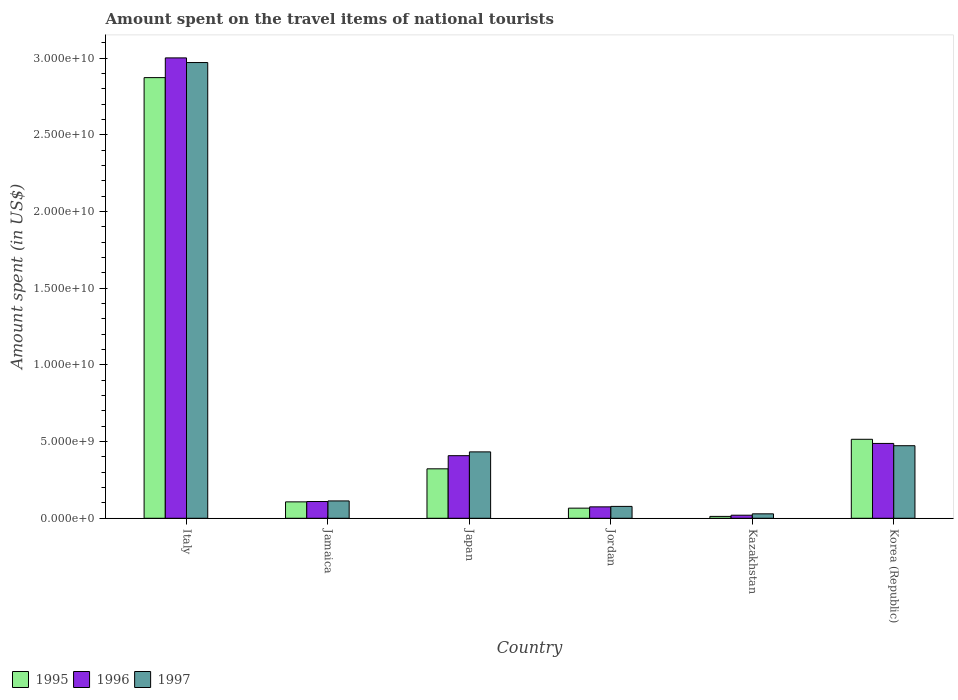Are the number of bars per tick equal to the number of legend labels?
Your answer should be compact. Yes. Are the number of bars on each tick of the X-axis equal?
Offer a very short reply. Yes. How many bars are there on the 4th tick from the left?
Your response must be concise. 3. In how many cases, is the number of bars for a given country not equal to the number of legend labels?
Your answer should be very brief. 0. What is the amount spent on the travel items of national tourists in 1995 in Italy?
Offer a terse response. 2.87e+1. Across all countries, what is the maximum amount spent on the travel items of national tourists in 1995?
Provide a succinct answer. 2.87e+1. Across all countries, what is the minimum amount spent on the travel items of national tourists in 1996?
Offer a terse response. 1.99e+08. In which country was the amount spent on the travel items of national tourists in 1996 minimum?
Provide a short and direct response. Kazakhstan. What is the total amount spent on the travel items of national tourists in 1996 in the graph?
Provide a succinct answer. 4.10e+1. What is the difference between the amount spent on the travel items of national tourists in 1996 in Italy and that in Japan?
Your answer should be compact. 2.59e+1. What is the difference between the amount spent on the travel items of national tourists in 1996 in Italy and the amount spent on the travel items of national tourists in 1997 in Kazakhstan?
Make the answer very short. 2.97e+1. What is the average amount spent on the travel items of national tourists in 1997 per country?
Give a very brief answer. 6.83e+09. What is the difference between the amount spent on the travel items of national tourists of/in 1997 and amount spent on the travel items of national tourists of/in 1996 in Japan?
Ensure brevity in your answer.  2.48e+08. In how many countries, is the amount spent on the travel items of national tourists in 1995 greater than 21000000000 US$?
Give a very brief answer. 1. What is the ratio of the amount spent on the travel items of national tourists in 1996 in Italy to that in Japan?
Provide a succinct answer. 7.36. Is the difference between the amount spent on the travel items of national tourists in 1997 in Jamaica and Japan greater than the difference between the amount spent on the travel items of national tourists in 1996 in Jamaica and Japan?
Provide a short and direct response. No. What is the difference between the highest and the second highest amount spent on the travel items of national tourists in 1995?
Provide a short and direct response. 2.55e+1. What is the difference between the highest and the lowest amount spent on the travel items of national tourists in 1997?
Your answer should be very brief. 2.94e+1. In how many countries, is the amount spent on the travel items of national tourists in 1997 greater than the average amount spent on the travel items of national tourists in 1997 taken over all countries?
Your response must be concise. 1. Is the sum of the amount spent on the travel items of national tourists in 1995 in Jamaica and Japan greater than the maximum amount spent on the travel items of national tourists in 1996 across all countries?
Keep it short and to the point. No. What does the 3rd bar from the left in Korea (Republic) represents?
Offer a terse response. 1997. What does the 1st bar from the right in Korea (Republic) represents?
Your answer should be compact. 1997. Is it the case that in every country, the sum of the amount spent on the travel items of national tourists in 1996 and amount spent on the travel items of national tourists in 1997 is greater than the amount spent on the travel items of national tourists in 1995?
Give a very brief answer. Yes. Are all the bars in the graph horizontal?
Your response must be concise. No. Does the graph contain any zero values?
Provide a short and direct response. No. Does the graph contain grids?
Your answer should be compact. No. What is the title of the graph?
Give a very brief answer. Amount spent on the travel items of national tourists. Does "1960" appear as one of the legend labels in the graph?
Offer a terse response. No. What is the label or title of the Y-axis?
Your answer should be very brief. Amount spent (in US$). What is the Amount spent (in US$) of 1995 in Italy?
Provide a short and direct response. 2.87e+1. What is the Amount spent (in US$) of 1996 in Italy?
Provide a short and direct response. 3.00e+1. What is the Amount spent (in US$) in 1997 in Italy?
Offer a very short reply. 2.97e+1. What is the Amount spent (in US$) of 1995 in Jamaica?
Offer a very short reply. 1.07e+09. What is the Amount spent (in US$) of 1996 in Jamaica?
Your answer should be very brief. 1.09e+09. What is the Amount spent (in US$) in 1997 in Jamaica?
Provide a succinct answer. 1.13e+09. What is the Amount spent (in US$) of 1995 in Japan?
Offer a terse response. 3.22e+09. What is the Amount spent (in US$) of 1996 in Japan?
Give a very brief answer. 4.08e+09. What is the Amount spent (in US$) in 1997 in Japan?
Give a very brief answer. 4.33e+09. What is the Amount spent (in US$) in 1995 in Jordan?
Provide a succinct answer. 6.60e+08. What is the Amount spent (in US$) of 1996 in Jordan?
Provide a short and direct response. 7.44e+08. What is the Amount spent (in US$) of 1997 in Jordan?
Offer a terse response. 7.74e+08. What is the Amount spent (in US$) of 1995 in Kazakhstan?
Give a very brief answer. 1.22e+08. What is the Amount spent (in US$) of 1996 in Kazakhstan?
Ensure brevity in your answer.  1.99e+08. What is the Amount spent (in US$) of 1997 in Kazakhstan?
Ensure brevity in your answer.  2.89e+08. What is the Amount spent (in US$) in 1995 in Korea (Republic)?
Your response must be concise. 5.15e+09. What is the Amount spent (in US$) of 1996 in Korea (Republic)?
Make the answer very short. 4.88e+09. What is the Amount spent (in US$) in 1997 in Korea (Republic)?
Offer a very short reply. 4.73e+09. Across all countries, what is the maximum Amount spent (in US$) in 1995?
Make the answer very short. 2.87e+1. Across all countries, what is the maximum Amount spent (in US$) of 1996?
Your answer should be very brief. 3.00e+1. Across all countries, what is the maximum Amount spent (in US$) of 1997?
Make the answer very short. 2.97e+1. Across all countries, what is the minimum Amount spent (in US$) of 1995?
Your response must be concise. 1.22e+08. Across all countries, what is the minimum Amount spent (in US$) in 1996?
Keep it short and to the point. 1.99e+08. Across all countries, what is the minimum Amount spent (in US$) in 1997?
Keep it short and to the point. 2.89e+08. What is the total Amount spent (in US$) of 1995 in the graph?
Offer a very short reply. 3.90e+1. What is the total Amount spent (in US$) of 1996 in the graph?
Your response must be concise. 4.10e+1. What is the total Amount spent (in US$) in 1997 in the graph?
Provide a short and direct response. 4.10e+1. What is the difference between the Amount spent (in US$) of 1995 in Italy and that in Jamaica?
Provide a short and direct response. 2.77e+1. What is the difference between the Amount spent (in US$) in 1996 in Italy and that in Jamaica?
Give a very brief answer. 2.89e+1. What is the difference between the Amount spent (in US$) of 1997 in Italy and that in Jamaica?
Offer a terse response. 2.86e+1. What is the difference between the Amount spent (in US$) of 1995 in Italy and that in Japan?
Keep it short and to the point. 2.55e+1. What is the difference between the Amount spent (in US$) in 1996 in Italy and that in Japan?
Your answer should be very brief. 2.59e+1. What is the difference between the Amount spent (in US$) of 1997 in Italy and that in Japan?
Provide a succinct answer. 2.54e+1. What is the difference between the Amount spent (in US$) in 1995 in Italy and that in Jordan?
Your answer should be compact. 2.81e+1. What is the difference between the Amount spent (in US$) in 1996 in Italy and that in Jordan?
Your answer should be compact. 2.93e+1. What is the difference between the Amount spent (in US$) of 1997 in Italy and that in Jordan?
Give a very brief answer. 2.89e+1. What is the difference between the Amount spent (in US$) in 1995 in Italy and that in Kazakhstan?
Keep it short and to the point. 2.86e+1. What is the difference between the Amount spent (in US$) in 1996 in Italy and that in Kazakhstan?
Keep it short and to the point. 2.98e+1. What is the difference between the Amount spent (in US$) in 1997 in Italy and that in Kazakhstan?
Keep it short and to the point. 2.94e+1. What is the difference between the Amount spent (in US$) in 1995 in Italy and that in Korea (Republic)?
Provide a short and direct response. 2.36e+1. What is the difference between the Amount spent (in US$) of 1996 in Italy and that in Korea (Republic)?
Make the answer very short. 2.51e+1. What is the difference between the Amount spent (in US$) in 1997 in Italy and that in Korea (Republic)?
Make the answer very short. 2.50e+1. What is the difference between the Amount spent (in US$) in 1995 in Jamaica and that in Japan?
Provide a short and direct response. -2.16e+09. What is the difference between the Amount spent (in US$) in 1996 in Jamaica and that in Japan?
Make the answer very short. -2.99e+09. What is the difference between the Amount spent (in US$) in 1997 in Jamaica and that in Japan?
Make the answer very short. -3.20e+09. What is the difference between the Amount spent (in US$) of 1995 in Jamaica and that in Jordan?
Give a very brief answer. 4.09e+08. What is the difference between the Amount spent (in US$) of 1996 in Jamaica and that in Jordan?
Keep it short and to the point. 3.48e+08. What is the difference between the Amount spent (in US$) of 1997 in Jamaica and that in Jordan?
Provide a succinct answer. 3.57e+08. What is the difference between the Amount spent (in US$) of 1995 in Jamaica and that in Kazakhstan?
Offer a terse response. 9.47e+08. What is the difference between the Amount spent (in US$) in 1996 in Jamaica and that in Kazakhstan?
Give a very brief answer. 8.93e+08. What is the difference between the Amount spent (in US$) in 1997 in Jamaica and that in Kazakhstan?
Offer a very short reply. 8.42e+08. What is the difference between the Amount spent (in US$) of 1995 in Jamaica and that in Korea (Republic)?
Offer a terse response. -4.08e+09. What is the difference between the Amount spent (in US$) of 1996 in Jamaica and that in Korea (Republic)?
Your response must be concise. -3.79e+09. What is the difference between the Amount spent (in US$) of 1997 in Jamaica and that in Korea (Republic)?
Provide a succinct answer. -3.60e+09. What is the difference between the Amount spent (in US$) in 1995 in Japan and that in Jordan?
Make the answer very short. 2.56e+09. What is the difference between the Amount spent (in US$) in 1996 in Japan and that in Jordan?
Your response must be concise. 3.34e+09. What is the difference between the Amount spent (in US$) in 1997 in Japan and that in Jordan?
Your answer should be compact. 3.56e+09. What is the difference between the Amount spent (in US$) in 1995 in Japan and that in Kazakhstan?
Make the answer very short. 3.10e+09. What is the difference between the Amount spent (in US$) of 1996 in Japan and that in Kazakhstan?
Make the answer very short. 3.88e+09. What is the difference between the Amount spent (in US$) of 1997 in Japan and that in Kazakhstan?
Keep it short and to the point. 4.04e+09. What is the difference between the Amount spent (in US$) of 1995 in Japan and that in Korea (Republic)?
Provide a succinct answer. -1.93e+09. What is the difference between the Amount spent (in US$) in 1996 in Japan and that in Korea (Republic)?
Your answer should be compact. -7.99e+08. What is the difference between the Amount spent (in US$) in 1997 in Japan and that in Korea (Republic)?
Offer a very short reply. -4.02e+08. What is the difference between the Amount spent (in US$) in 1995 in Jordan and that in Kazakhstan?
Give a very brief answer. 5.38e+08. What is the difference between the Amount spent (in US$) in 1996 in Jordan and that in Kazakhstan?
Make the answer very short. 5.45e+08. What is the difference between the Amount spent (in US$) of 1997 in Jordan and that in Kazakhstan?
Provide a succinct answer. 4.85e+08. What is the difference between the Amount spent (in US$) in 1995 in Jordan and that in Korea (Republic)?
Ensure brevity in your answer.  -4.49e+09. What is the difference between the Amount spent (in US$) in 1996 in Jordan and that in Korea (Republic)?
Offer a very short reply. -4.14e+09. What is the difference between the Amount spent (in US$) of 1997 in Jordan and that in Korea (Republic)?
Offer a terse response. -3.96e+09. What is the difference between the Amount spent (in US$) of 1995 in Kazakhstan and that in Korea (Republic)?
Your response must be concise. -5.03e+09. What is the difference between the Amount spent (in US$) of 1996 in Kazakhstan and that in Korea (Republic)?
Offer a terse response. -4.68e+09. What is the difference between the Amount spent (in US$) in 1997 in Kazakhstan and that in Korea (Republic)?
Your answer should be compact. -4.44e+09. What is the difference between the Amount spent (in US$) in 1995 in Italy and the Amount spent (in US$) in 1996 in Jamaica?
Keep it short and to the point. 2.76e+1. What is the difference between the Amount spent (in US$) of 1995 in Italy and the Amount spent (in US$) of 1997 in Jamaica?
Give a very brief answer. 2.76e+1. What is the difference between the Amount spent (in US$) in 1996 in Italy and the Amount spent (in US$) in 1997 in Jamaica?
Your answer should be compact. 2.89e+1. What is the difference between the Amount spent (in US$) of 1995 in Italy and the Amount spent (in US$) of 1996 in Japan?
Ensure brevity in your answer.  2.46e+1. What is the difference between the Amount spent (in US$) in 1995 in Italy and the Amount spent (in US$) in 1997 in Japan?
Offer a very short reply. 2.44e+1. What is the difference between the Amount spent (in US$) of 1996 in Italy and the Amount spent (in US$) of 1997 in Japan?
Offer a very short reply. 2.57e+1. What is the difference between the Amount spent (in US$) in 1995 in Italy and the Amount spent (in US$) in 1996 in Jordan?
Give a very brief answer. 2.80e+1. What is the difference between the Amount spent (in US$) in 1995 in Italy and the Amount spent (in US$) in 1997 in Jordan?
Your answer should be compact. 2.80e+1. What is the difference between the Amount spent (in US$) in 1996 in Italy and the Amount spent (in US$) in 1997 in Jordan?
Keep it short and to the point. 2.92e+1. What is the difference between the Amount spent (in US$) in 1995 in Italy and the Amount spent (in US$) in 1996 in Kazakhstan?
Make the answer very short. 2.85e+1. What is the difference between the Amount spent (in US$) of 1995 in Italy and the Amount spent (in US$) of 1997 in Kazakhstan?
Make the answer very short. 2.84e+1. What is the difference between the Amount spent (in US$) of 1996 in Italy and the Amount spent (in US$) of 1997 in Kazakhstan?
Give a very brief answer. 2.97e+1. What is the difference between the Amount spent (in US$) of 1995 in Italy and the Amount spent (in US$) of 1996 in Korea (Republic)?
Your answer should be compact. 2.39e+1. What is the difference between the Amount spent (in US$) in 1995 in Italy and the Amount spent (in US$) in 1997 in Korea (Republic)?
Make the answer very short. 2.40e+1. What is the difference between the Amount spent (in US$) in 1996 in Italy and the Amount spent (in US$) in 1997 in Korea (Republic)?
Your answer should be compact. 2.53e+1. What is the difference between the Amount spent (in US$) of 1995 in Jamaica and the Amount spent (in US$) of 1996 in Japan?
Offer a terse response. -3.01e+09. What is the difference between the Amount spent (in US$) in 1995 in Jamaica and the Amount spent (in US$) in 1997 in Japan?
Your answer should be compact. -3.26e+09. What is the difference between the Amount spent (in US$) in 1996 in Jamaica and the Amount spent (in US$) in 1997 in Japan?
Offer a terse response. -3.24e+09. What is the difference between the Amount spent (in US$) of 1995 in Jamaica and the Amount spent (in US$) of 1996 in Jordan?
Offer a very short reply. 3.25e+08. What is the difference between the Amount spent (in US$) of 1995 in Jamaica and the Amount spent (in US$) of 1997 in Jordan?
Your answer should be very brief. 2.95e+08. What is the difference between the Amount spent (in US$) of 1996 in Jamaica and the Amount spent (in US$) of 1997 in Jordan?
Keep it short and to the point. 3.18e+08. What is the difference between the Amount spent (in US$) in 1995 in Jamaica and the Amount spent (in US$) in 1996 in Kazakhstan?
Make the answer very short. 8.70e+08. What is the difference between the Amount spent (in US$) in 1995 in Jamaica and the Amount spent (in US$) in 1997 in Kazakhstan?
Offer a very short reply. 7.80e+08. What is the difference between the Amount spent (in US$) of 1996 in Jamaica and the Amount spent (in US$) of 1997 in Kazakhstan?
Offer a very short reply. 8.03e+08. What is the difference between the Amount spent (in US$) in 1995 in Jamaica and the Amount spent (in US$) in 1996 in Korea (Republic)?
Provide a short and direct response. -3.81e+09. What is the difference between the Amount spent (in US$) of 1995 in Jamaica and the Amount spent (in US$) of 1997 in Korea (Republic)?
Provide a succinct answer. -3.66e+09. What is the difference between the Amount spent (in US$) of 1996 in Jamaica and the Amount spent (in US$) of 1997 in Korea (Republic)?
Keep it short and to the point. -3.64e+09. What is the difference between the Amount spent (in US$) of 1995 in Japan and the Amount spent (in US$) of 1996 in Jordan?
Your response must be concise. 2.48e+09. What is the difference between the Amount spent (in US$) of 1995 in Japan and the Amount spent (in US$) of 1997 in Jordan?
Keep it short and to the point. 2.45e+09. What is the difference between the Amount spent (in US$) in 1996 in Japan and the Amount spent (in US$) in 1997 in Jordan?
Offer a very short reply. 3.31e+09. What is the difference between the Amount spent (in US$) of 1995 in Japan and the Amount spent (in US$) of 1996 in Kazakhstan?
Your answer should be compact. 3.02e+09. What is the difference between the Amount spent (in US$) in 1995 in Japan and the Amount spent (in US$) in 1997 in Kazakhstan?
Offer a terse response. 2.94e+09. What is the difference between the Amount spent (in US$) of 1996 in Japan and the Amount spent (in US$) of 1997 in Kazakhstan?
Make the answer very short. 3.79e+09. What is the difference between the Amount spent (in US$) in 1995 in Japan and the Amount spent (in US$) in 1996 in Korea (Republic)?
Keep it short and to the point. -1.66e+09. What is the difference between the Amount spent (in US$) in 1995 in Japan and the Amount spent (in US$) in 1997 in Korea (Republic)?
Your response must be concise. -1.51e+09. What is the difference between the Amount spent (in US$) of 1996 in Japan and the Amount spent (in US$) of 1997 in Korea (Republic)?
Offer a terse response. -6.50e+08. What is the difference between the Amount spent (in US$) in 1995 in Jordan and the Amount spent (in US$) in 1996 in Kazakhstan?
Your answer should be compact. 4.61e+08. What is the difference between the Amount spent (in US$) of 1995 in Jordan and the Amount spent (in US$) of 1997 in Kazakhstan?
Keep it short and to the point. 3.71e+08. What is the difference between the Amount spent (in US$) in 1996 in Jordan and the Amount spent (in US$) in 1997 in Kazakhstan?
Keep it short and to the point. 4.55e+08. What is the difference between the Amount spent (in US$) of 1995 in Jordan and the Amount spent (in US$) of 1996 in Korea (Republic)?
Keep it short and to the point. -4.22e+09. What is the difference between the Amount spent (in US$) in 1995 in Jordan and the Amount spent (in US$) in 1997 in Korea (Republic)?
Your answer should be compact. -4.07e+09. What is the difference between the Amount spent (in US$) in 1996 in Jordan and the Amount spent (in US$) in 1997 in Korea (Republic)?
Provide a succinct answer. -3.99e+09. What is the difference between the Amount spent (in US$) in 1995 in Kazakhstan and the Amount spent (in US$) in 1996 in Korea (Republic)?
Your answer should be compact. -4.76e+09. What is the difference between the Amount spent (in US$) of 1995 in Kazakhstan and the Amount spent (in US$) of 1997 in Korea (Republic)?
Provide a short and direct response. -4.61e+09. What is the difference between the Amount spent (in US$) of 1996 in Kazakhstan and the Amount spent (in US$) of 1997 in Korea (Republic)?
Ensure brevity in your answer.  -4.53e+09. What is the average Amount spent (in US$) of 1995 per country?
Make the answer very short. 6.49e+09. What is the average Amount spent (in US$) in 1996 per country?
Your response must be concise. 6.84e+09. What is the average Amount spent (in US$) of 1997 per country?
Your answer should be very brief. 6.83e+09. What is the difference between the Amount spent (in US$) of 1995 and Amount spent (in US$) of 1996 in Italy?
Give a very brief answer. -1.29e+09. What is the difference between the Amount spent (in US$) of 1995 and Amount spent (in US$) of 1997 in Italy?
Give a very brief answer. -9.83e+08. What is the difference between the Amount spent (in US$) of 1996 and Amount spent (in US$) of 1997 in Italy?
Provide a short and direct response. 3.03e+08. What is the difference between the Amount spent (in US$) in 1995 and Amount spent (in US$) in 1996 in Jamaica?
Keep it short and to the point. -2.30e+07. What is the difference between the Amount spent (in US$) of 1995 and Amount spent (in US$) of 1997 in Jamaica?
Provide a short and direct response. -6.20e+07. What is the difference between the Amount spent (in US$) in 1996 and Amount spent (in US$) in 1997 in Jamaica?
Make the answer very short. -3.90e+07. What is the difference between the Amount spent (in US$) in 1995 and Amount spent (in US$) in 1996 in Japan?
Give a very brief answer. -8.57e+08. What is the difference between the Amount spent (in US$) of 1995 and Amount spent (in US$) of 1997 in Japan?
Your answer should be compact. -1.10e+09. What is the difference between the Amount spent (in US$) of 1996 and Amount spent (in US$) of 1997 in Japan?
Keep it short and to the point. -2.48e+08. What is the difference between the Amount spent (in US$) of 1995 and Amount spent (in US$) of 1996 in Jordan?
Provide a succinct answer. -8.40e+07. What is the difference between the Amount spent (in US$) of 1995 and Amount spent (in US$) of 1997 in Jordan?
Offer a very short reply. -1.14e+08. What is the difference between the Amount spent (in US$) of 1996 and Amount spent (in US$) of 1997 in Jordan?
Ensure brevity in your answer.  -3.00e+07. What is the difference between the Amount spent (in US$) in 1995 and Amount spent (in US$) in 1996 in Kazakhstan?
Make the answer very short. -7.70e+07. What is the difference between the Amount spent (in US$) of 1995 and Amount spent (in US$) of 1997 in Kazakhstan?
Your response must be concise. -1.67e+08. What is the difference between the Amount spent (in US$) in 1996 and Amount spent (in US$) in 1997 in Kazakhstan?
Ensure brevity in your answer.  -9.00e+07. What is the difference between the Amount spent (in US$) of 1995 and Amount spent (in US$) of 1996 in Korea (Republic)?
Offer a very short reply. 2.70e+08. What is the difference between the Amount spent (in US$) of 1995 and Amount spent (in US$) of 1997 in Korea (Republic)?
Provide a short and direct response. 4.19e+08. What is the difference between the Amount spent (in US$) in 1996 and Amount spent (in US$) in 1997 in Korea (Republic)?
Ensure brevity in your answer.  1.49e+08. What is the ratio of the Amount spent (in US$) of 1995 in Italy to that in Jamaica?
Your answer should be very brief. 26.88. What is the ratio of the Amount spent (in US$) of 1996 in Italy to that in Jamaica?
Make the answer very short. 27.49. What is the ratio of the Amount spent (in US$) in 1997 in Italy to that in Jamaica?
Provide a short and direct response. 26.27. What is the ratio of the Amount spent (in US$) in 1995 in Italy to that in Japan?
Your answer should be very brief. 8.91. What is the ratio of the Amount spent (in US$) of 1996 in Italy to that in Japan?
Your answer should be very brief. 7.36. What is the ratio of the Amount spent (in US$) in 1997 in Italy to that in Japan?
Your response must be concise. 6.86. What is the ratio of the Amount spent (in US$) in 1995 in Italy to that in Jordan?
Ensure brevity in your answer.  43.53. What is the ratio of the Amount spent (in US$) in 1996 in Italy to that in Jordan?
Make the answer very short. 40.35. What is the ratio of the Amount spent (in US$) in 1997 in Italy to that in Jordan?
Your answer should be very brief. 38.39. What is the ratio of the Amount spent (in US$) of 1995 in Italy to that in Kazakhstan?
Provide a succinct answer. 235.5. What is the ratio of the Amount spent (in US$) in 1996 in Italy to that in Kazakhstan?
Keep it short and to the point. 150.84. What is the ratio of the Amount spent (in US$) in 1997 in Italy to that in Kazakhstan?
Your answer should be compact. 102.82. What is the ratio of the Amount spent (in US$) of 1995 in Italy to that in Korea (Republic)?
Keep it short and to the point. 5.58. What is the ratio of the Amount spent (in US$) in 1996 in Italy to that in Korea (Republic)?
Your response must be concise. 6.15. What is the ratio of the Amount spent (in US$) in 1997 in Italy to that in Korea (Republic)?
Your answer should be very brief. 6.28. What is the ratio of the Amount spent (in US$) in 1995 in Jamaica to that in Japan?
Your response must be concise. 0.33. What is the ratio of the Amount spent (in US$) in 1996 in Jamaica to that in Japan?
Your answer should be compact. 0.27. What is the ratio of the Amount spent (in US$) of 1997 in Jamaica to that in Japan?
Keep it short and to the point. 0.26. What is the ratio of the Amount spent (in US$) in 1995 in Jamaica to that in Jordan?
Make the answer very short. 1.62. What is the ratio of the Amount spent (in US$) of 1996 in Jamaica to that in Jordan?
Offer a very short reply. 1.47. What is the ratio of the Amount spent (in US$) of 1997 in Jamaica to that in Jordan?
Your response must be concise. 1.46. What is the ratio of the Amount spent (in US$) in 1995 in Jamaica to that in Kazakhstan?
Provide a succinct answer. 8.76. What is the ratio of the Amount spent (in US$) of 1996 in Jamaica to that in Kazakhstan?
Make the answer very short. 5.49. What is the ratio of the Amount spent (in US$) in 1997 in Jamaica to that in Kazakhstan?
Offer a very short reply. 3.91. What is the ratio of the Amount spent (in US$) in 1995 in Jamaica to that in Korea (Republic)?
Ensure brevity in your answer.  0.21. What is the ratio of the Amount spent (in US$) in 1996 in Jamaica to that in Korea (Republic)?
Provide a succinct answer. 0.22. What is the ratio of the Amount spent (in US$) of 1997 in Jamaica to that in Korea (Republic)?
Offer a very short reply. 0.24. What is the ratio of the Amount spent (in US$) of 1995 in Japan to that in Jordan?
Your answer should be very brief. 4.88. What is the ratio of the Amount spent (in US$) of 1996 in Japan to that in Jordan?
Provide a succinct answer. 5.49. What is the ratio of the Amount spent (in US$) of 1997 in Japan to that in Jordan?
Provide a succinct answer. 5.59. What is the ratio of the Amount spent (in US$) in 1995 in Japan to that in Kazakhstan?
Your answer should be compact. 26.43. What is the ratio of the Amount spent (in US$) of 1996 in Japan to that in Kazakhstan?
Provide a short and direct response. 20.51. What is the ratio of the Amount spent (in US$) in 1997 in Japan to that in Kazakhstan?
Make the answer very short. 14.98. What is the ratio of the Amount spent (in US$) of 1995 in Japan to that in Korea (Republic)?
Your response must be concise. 0.63. What is the ratio of the Amount spent (in US$) in 1996 in Japan to that in Korea (Republic)?
Ensure brevity in your answer.  0.84. What is the ratio of the Amount spent (in US$) of 1997 in Japan to that in Korea (Republic)?
Make the answer very short. 0.92. What is the ratio of the Amount spent (in US$) of 1995 in Jordan to that in Kazakhstan?
Provide a short and direct response. 5.41. What is the ratio of the Amount spent (in US$) of 1996 in Jordan to that in Kazakhstan?
Offer a terse response. 3.74. What is the ratio of the Amount spent (in US$) of 1997 in Jordan to that in Kazakhstan?
Ensure brevity in your answer.  2.68. What is the ratio of the Amount spent (in US$) of 1995 in Jordan to that in Korea (Republic)?
Provide a short and direct response. 0.13. What is the ratio of the Amount spent (in US$) of 1996 in Jordan to that in Korea (Republic)?
Your answer should be compact. 0.15. What is the ratio of the Amount spent (in US$) of 1997 in Jordan to that in Korea (Republic)?
Ensure brevity in your answer.  0.16. What is the ratio of the Amount spent (in US$) in 1995 in Kazakhstan to that in Korea (Republic)?
Provide a short and direct response. 0.02. What is the ratio of the Amount spent (in US$) of 1996 in Kazakhstan to that in Korea (Republic)?
Keep it short and to the point. 0.04. What is the ratio of the Amount spent (in US$) of 1997 in Kazakhstan to that in Korea (Republic)?
Offer a very short reply. 0.06. What is the difference between the highest and the second highest Amount spent (in US$) of 1995?
Offer a very short reply. 2.36e+1. What is the difference between the highest and the second highest Amount spent (in US$) of 1996?
Keep it short and to the point. 2.51e+1. What is the difference between the highest and the second highest Amount spent (in US$) in 1997?
Provide a succinct answer. 2.50e+1. What is the difference between the highest and the lowest Amount spent (in US$) in 1995?
Provide a short and direct response. 2.86e+1. What is the difference between the highest and the lowest Amount spent (in US$) of 1996?
Your answer should be compact. 2.98e+1. What is the difference between the highest and the lowest Amount spent (in US$) of 1997?
Your response must be concise. 2.94e+1. 